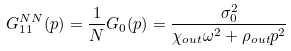Convert formula to latex. <formula><loc_0><loc_0><loc_500><loc_500>G _ { 1 1 } ^ { N N } ( p ) = \frac { 1 } { N } G _ { 0 } ( p ) = \frac { \sigma _ { 0 } ^ { 2 } } { \chi _ { o u t } \omega ^ { 2 } + \rho _ { o u t } p ^ { 2 } }</formula> 